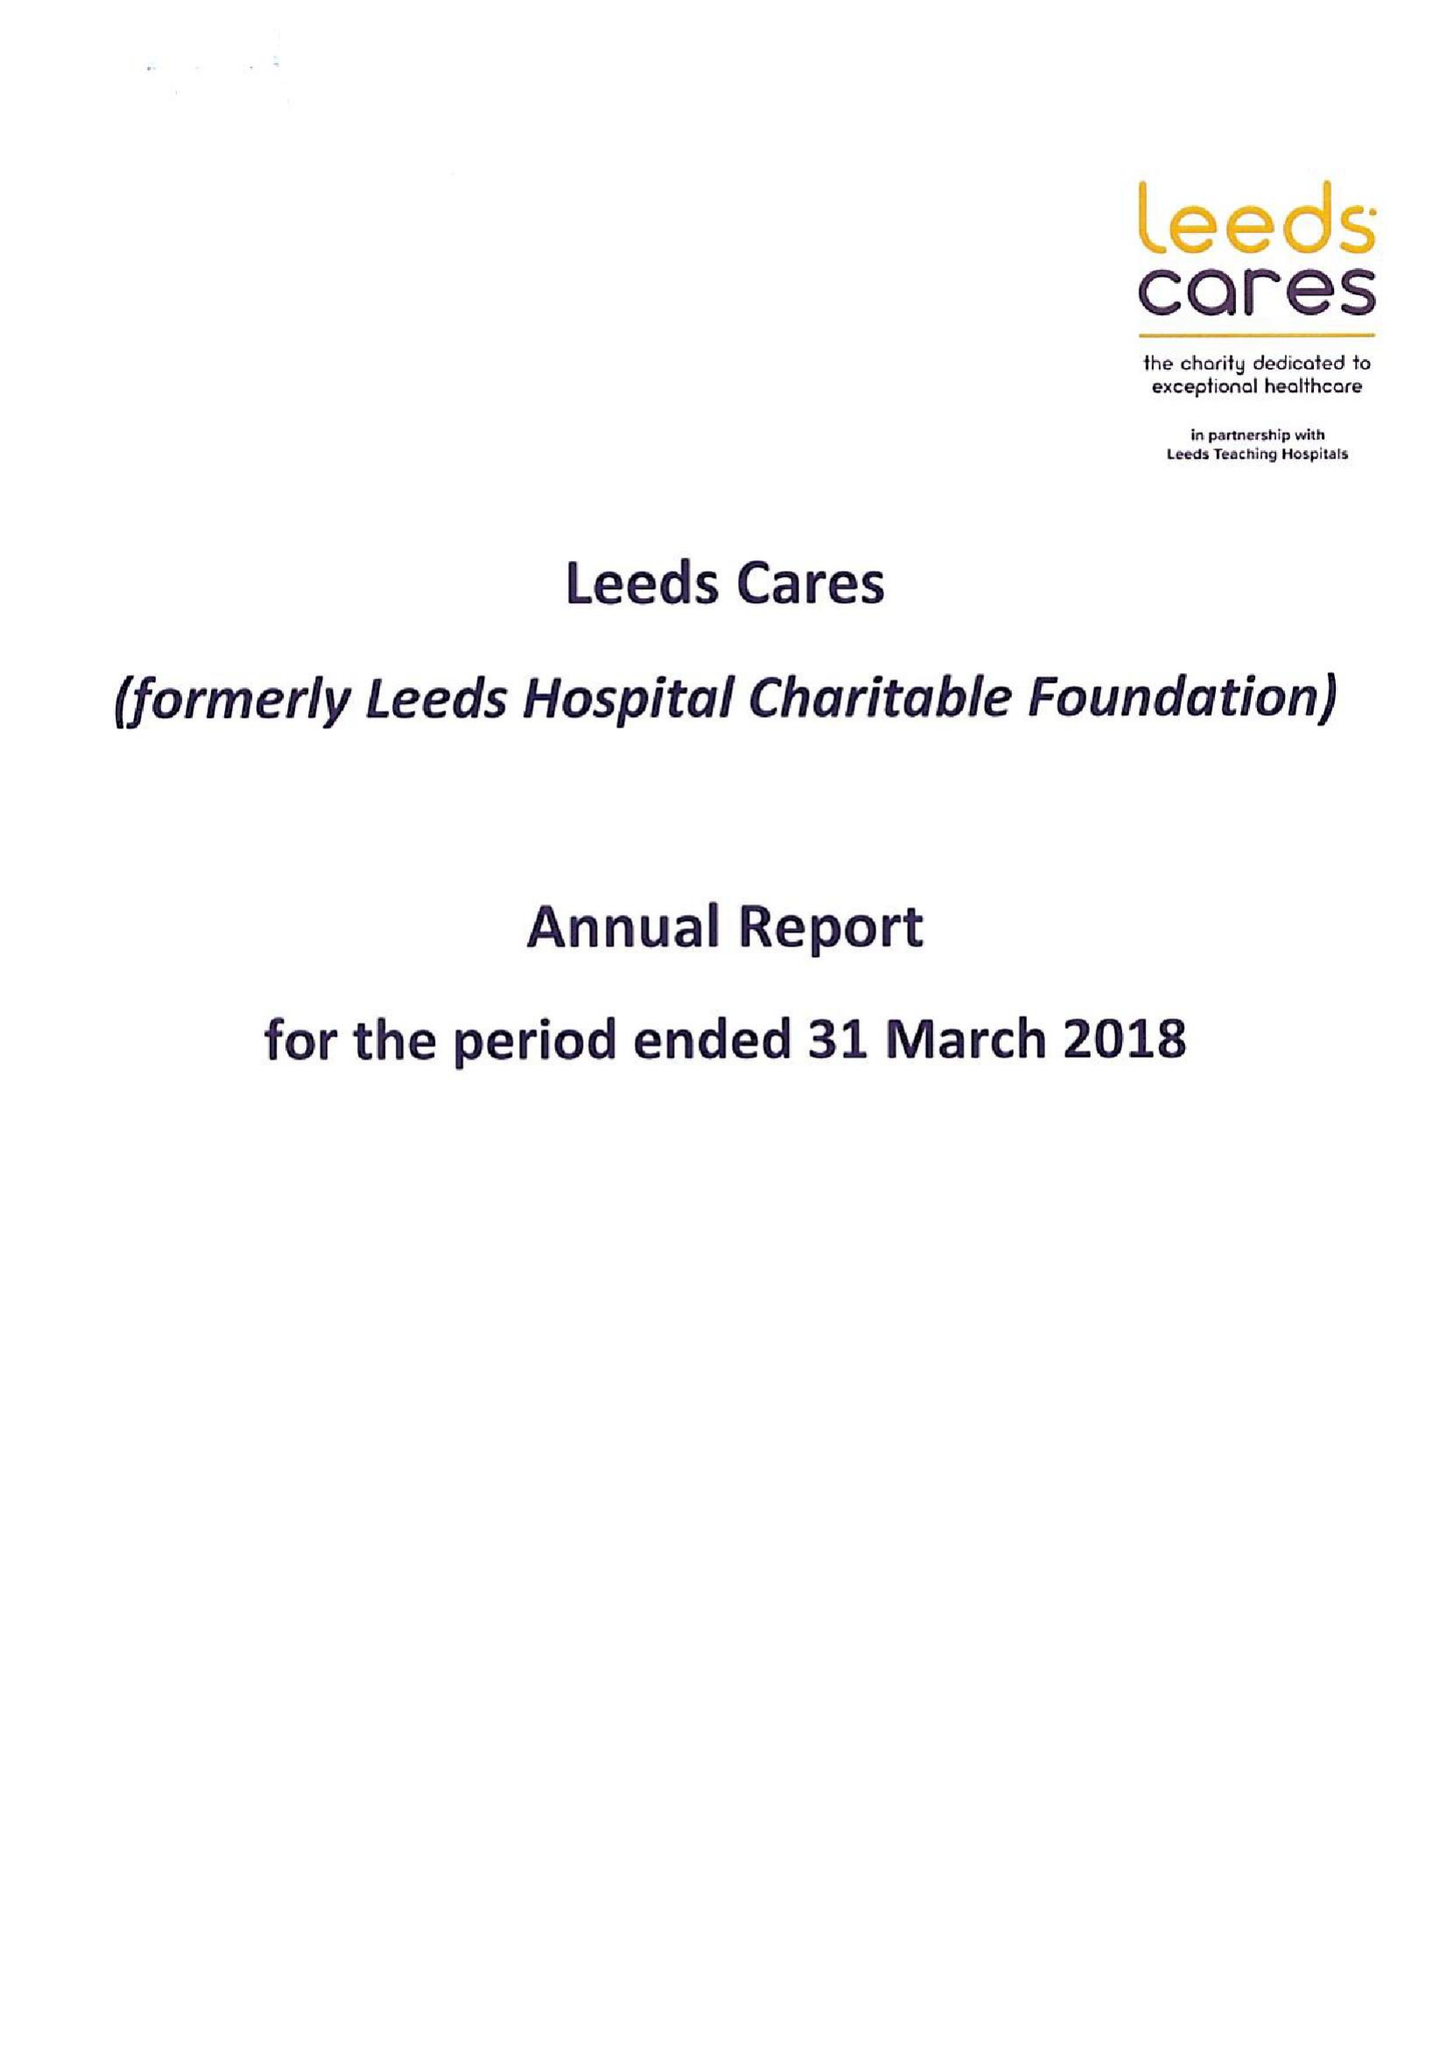What is the value for the spending_annually_in_british_pounds?
Answer the question using a single word or phrase. 11462000.00 